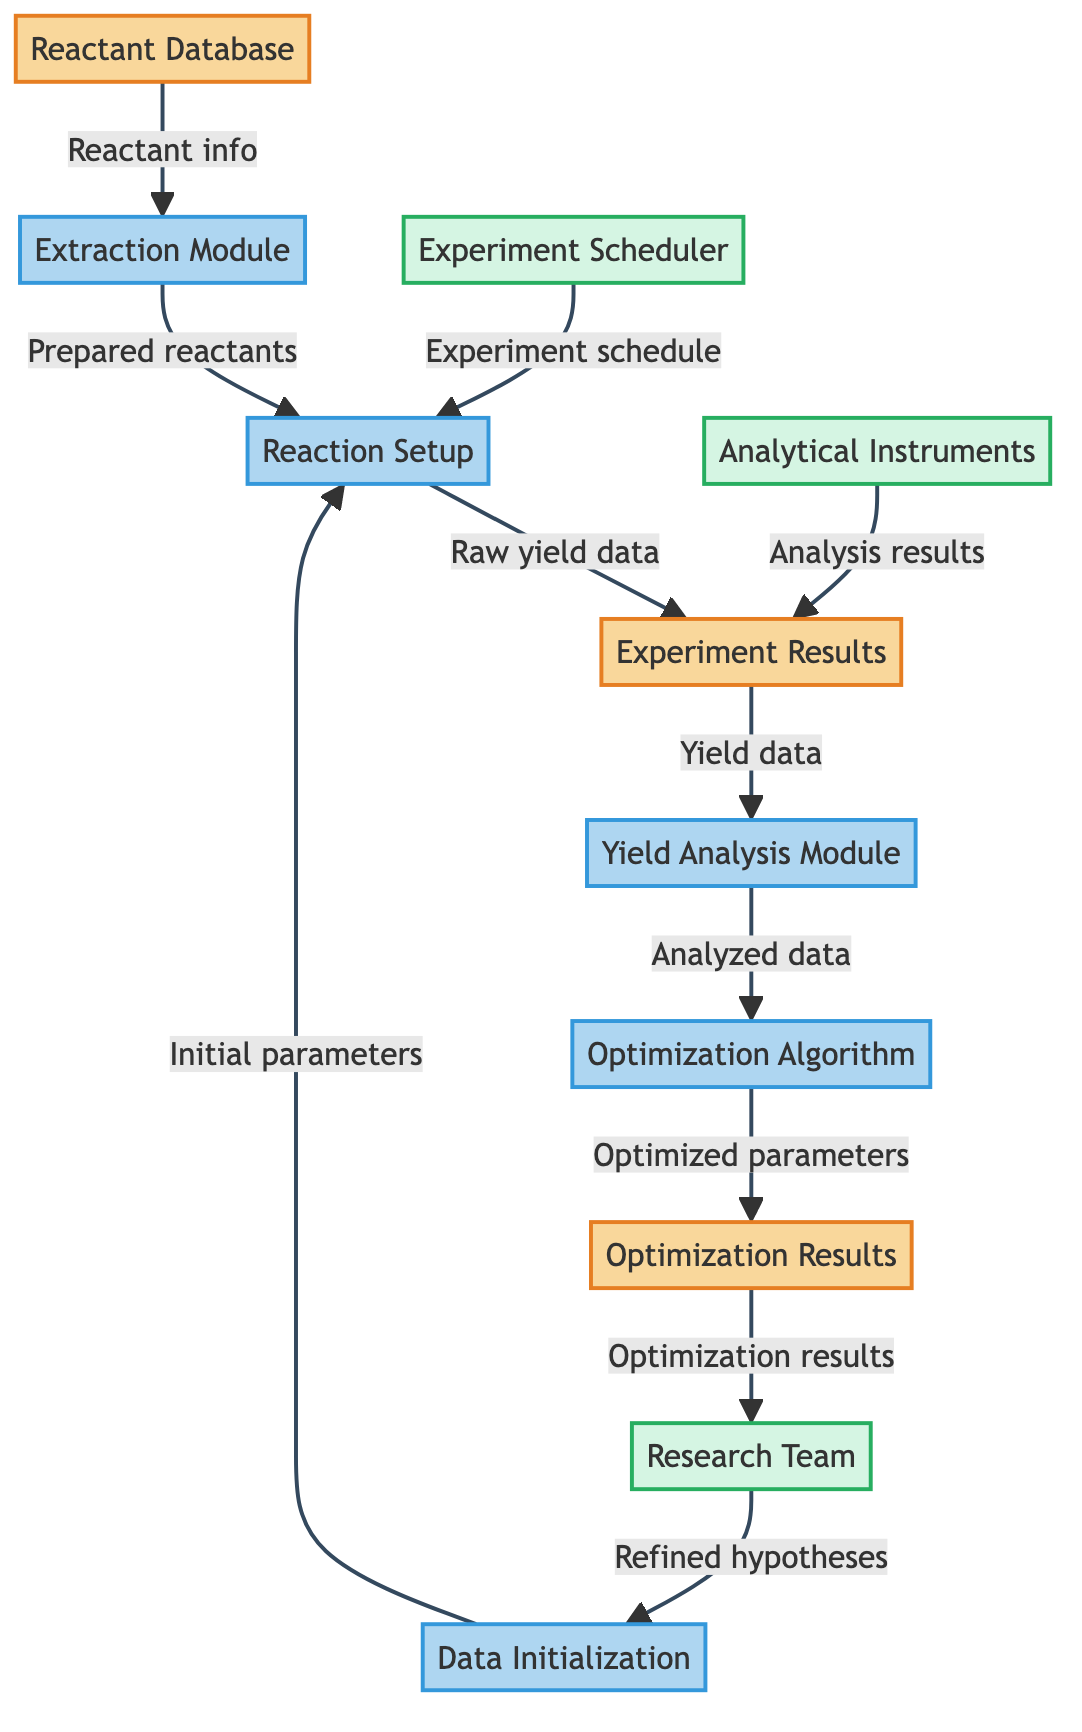What type of element is the "Reactant Database"? The "Reactant Database" is defined as a "Data Store" in the diagram legend, indicating that it holds information rather than performing a process or acting as an external entity.
Answer: Data Store How many processes are represented in the diagram? The diagram includes five processes: Extraction Module, Reaction Setup, Data Initialization, Yield Analysis Module, and Optimization Algorithm. Counting these gives a total of five processes.
Answer: 5 What is the relationship between the "Experiment Results" and the "Yield Analysis Module"? The "Experiment Results" provides "Yield data" to the "Yield Analysis Module," indicating that the analysis module uses this data to perform its calculations.
Answer: Yield data Which external entity interacts with the "Experiment Setup"? Both the "Analytical Instruments" and "Experiment Scheduler" interact with the "Reaction Setup"; however, only the Experiment Scheduler has a direct flow to it, indicating a scheduling action.
Answer: Experiment Scheduler What is the purpose of the "Optimization Algorithm"? The "Optimization Algorithm" is described as being responsible for "adjusting parameters and suggesting new configurations based on previous yield data," illustrating its role in enhancing reaction outcomes.
Answer: Adjusting parameters How does the "Research Team" contribute to the process flow? The "Research Team" receives "Optimization results," which they then use to refine hypotheses and provide "Initial parameters" back into the data initialization stage, demonstrating their integral role in the iterative process.
Answer: Refining hypotheses What types of data are stored in the "Experiment Results"? The "Experiment Results" data repository is specifically stated to store "raw yield data, byproducts, and conditions under which each reaction was carried out," detailing the comprehensive data collected from experiments.
Answer: Raw yield data, byproducts, conditions What does the "Yield Analysis Module" produce? The "Yield Analysis Module" outputs "Analyzed data," which incorporates processed information and yield calculations, indicating its function in the overall analysis of experimental results.
Answer: Analyzed data Which element collects the initial parameters before experiments? The "Data Initialization" process is designated to collect "Initial parameters" before executing the experiments, setting the groundwork for subsequent stages in the experiment flow.
Answer: Data Initialization 